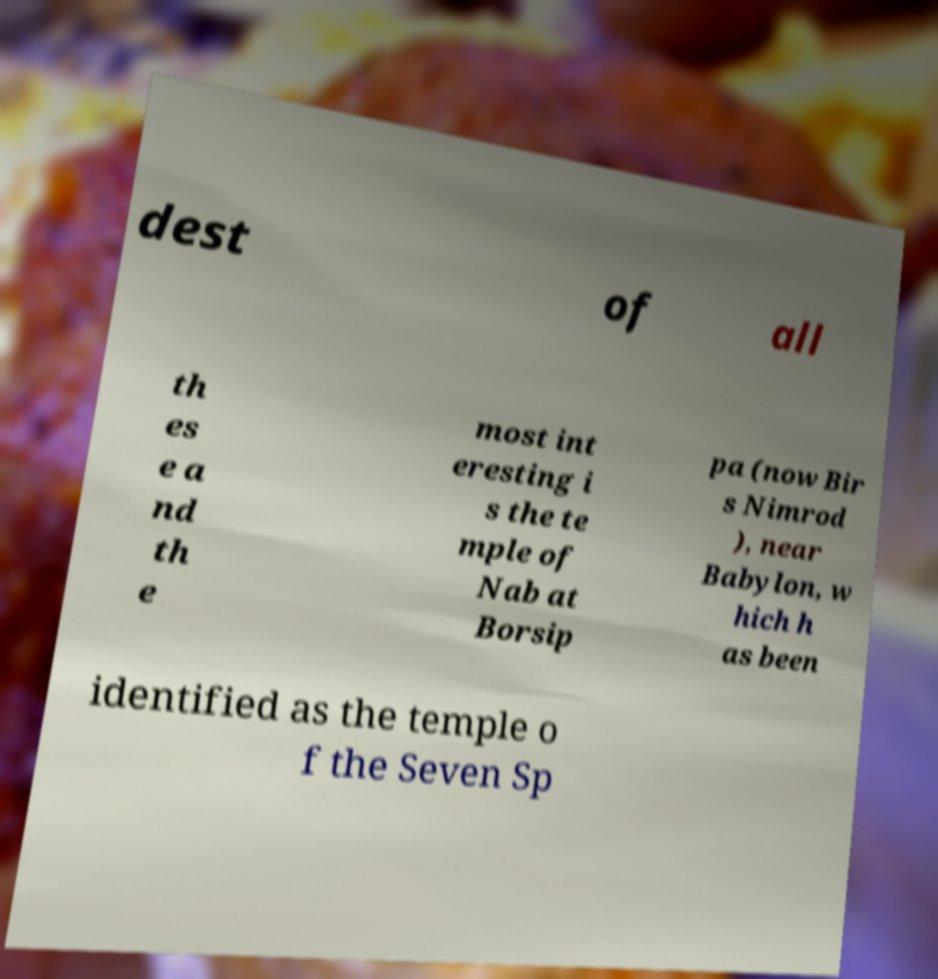Can you accurately transcribe the text from the provided image for me? dest of all th es e a nd th e most int eresting i s the te mple of Nab at Borsip pa (now Bir s Nimrod ), near Babylon, w hich h as been identified as the temple o f the Seven Sp 